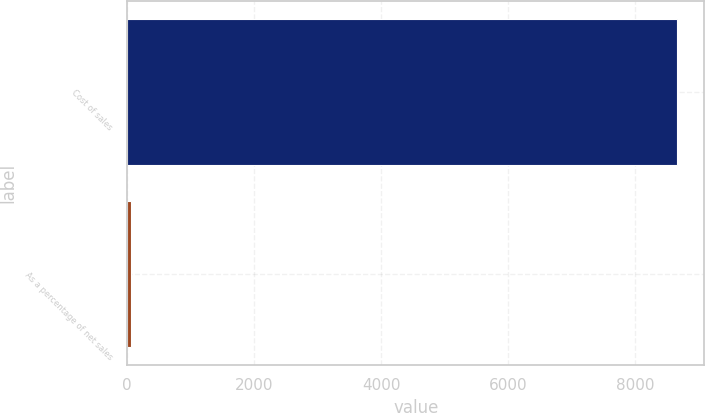Convert chart. <chart><loc_0><loc_0><loc_500><loc_500><bar_chart><fcel>Cost of sales<fcel>As a percentage of net sales<nl><fcel>8663<fcel>66.1<nl></chart> 